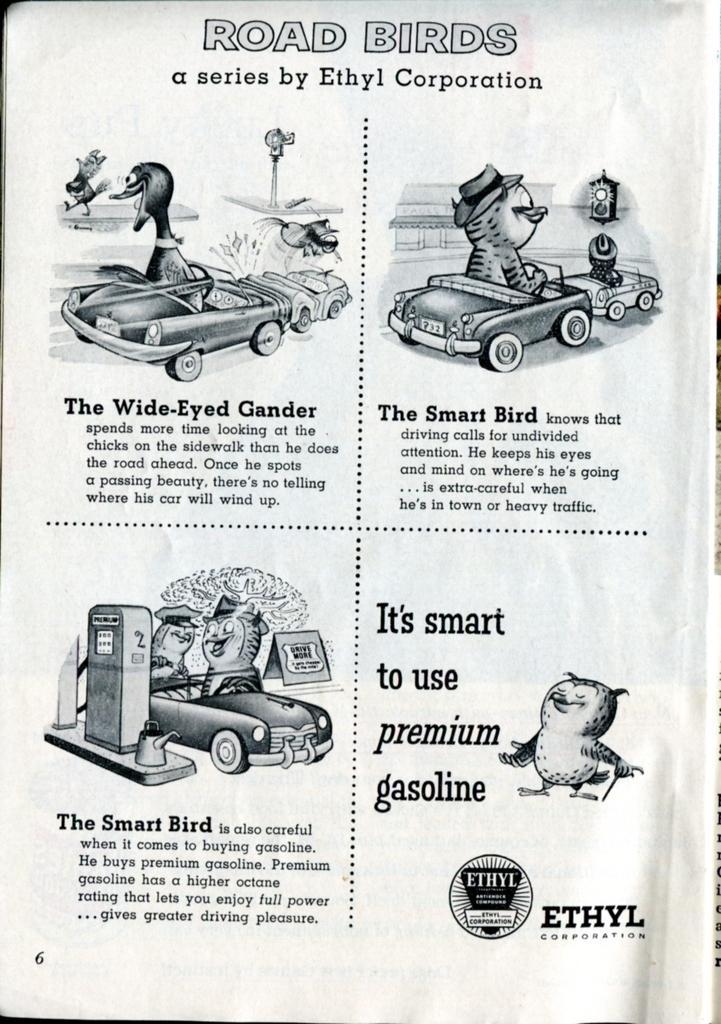Can you describe this image briefly? In this image we can see the page of the book in which a cartoons are there. In this image story of the cartoon is described about it. 